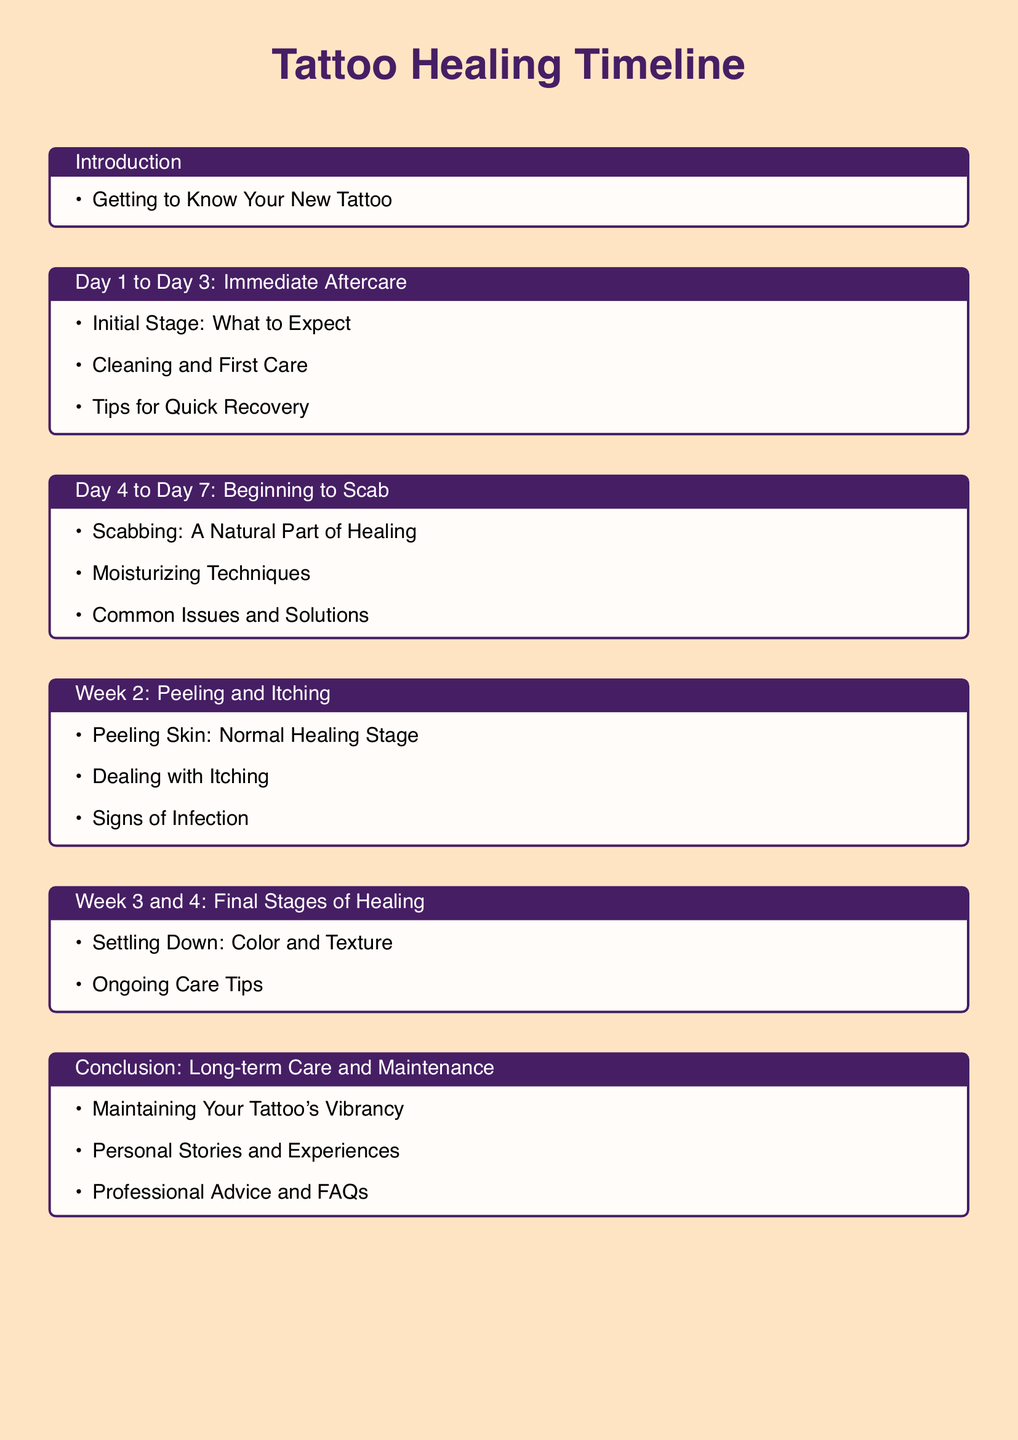What is the title of the document? The title of the document is indicated at the beginning of the rendered content.
Answer: Tattoo Healing Timeline What are the first three days referred to in the document? The document details stages of healing, and the first segment covers the immediate aftercare phase.
Answer: Immediate Aftercare What should you expect in the scabbing stage? The scabbing stage is highlighted as a natural part of healing, providing insight into the process.
Answer: A Natural Part of Healing What common issue is discussed in the peeling stage? The document outlines potential concerns like itching that may arise as the skin peels.
Answer: Itching How many weeks does the final stages of healing encompass? The final stages of healing are discussed over a period of two weeks.
Answer: 2 weeks What are the long-term care suggestions? The conclusion section provides guidance for maintaining the tattoo's appearance in the long term.
Answer: Maintaining Your Tattoo's Vibrancy What type of stories are included in the conclusion? The conclusion includes personal stories that offer insights and experiences related to tattoo care.
Answer: Personal Stories and Experiences What is one method of care mentioned for the peeling skin? The document suggests focusing on moisturizing techniques during the peeling stage.
Answer: Moisturizing Techniques 